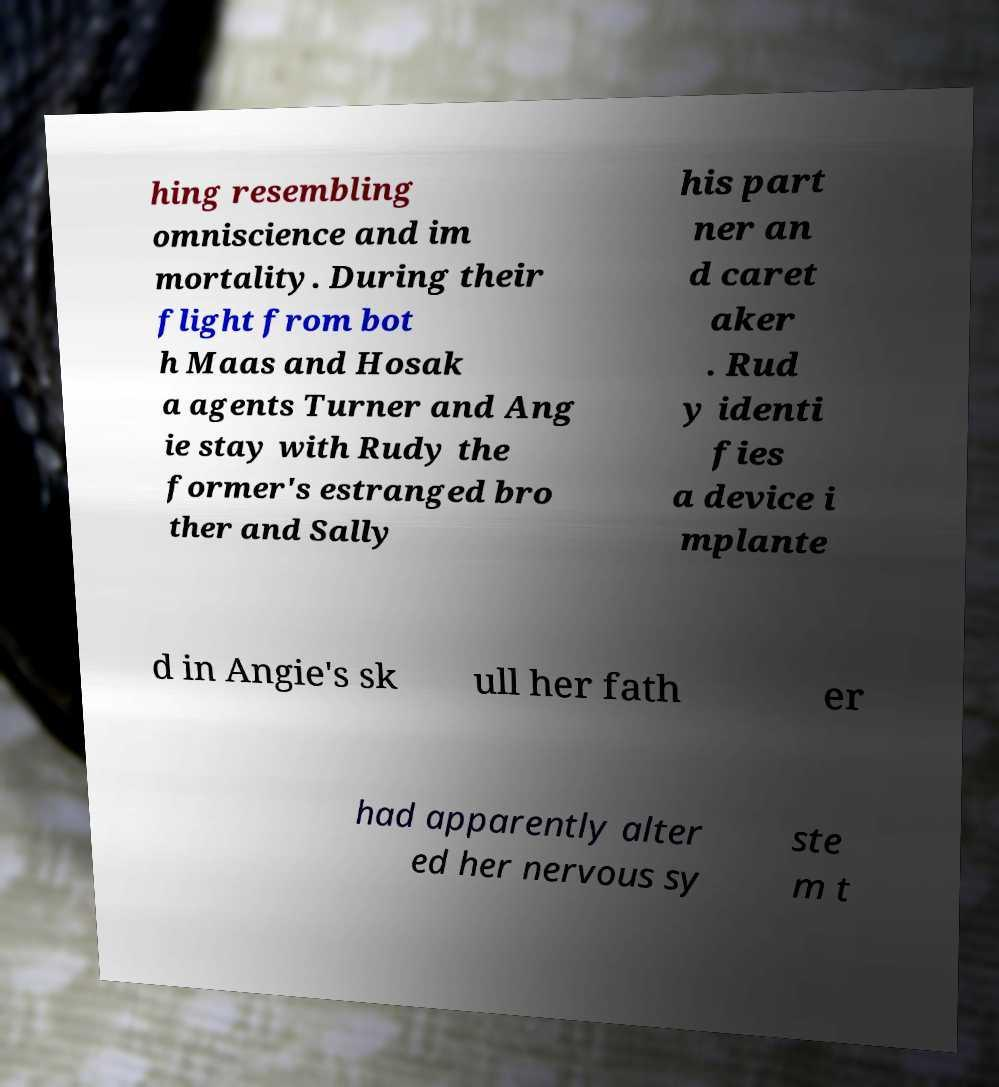Could you extract and type out the text from this image? hing resembling omniscience and im mortality. During their flight from bot h Maas and Hosak a agents Turner and Ang ie stay with Rudy the former's estranged bro ther and Sally his part ner an d caret aker . Rud y identi fies a device i mplante d in Angie's sk ull her fath er had apparently alter ed her nervous sy ste m t 